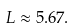Convert formula to latex. <formula><loc_0><loc_0><loc_500><loc_500>L \approx 5 . 6 7 .</formula> 